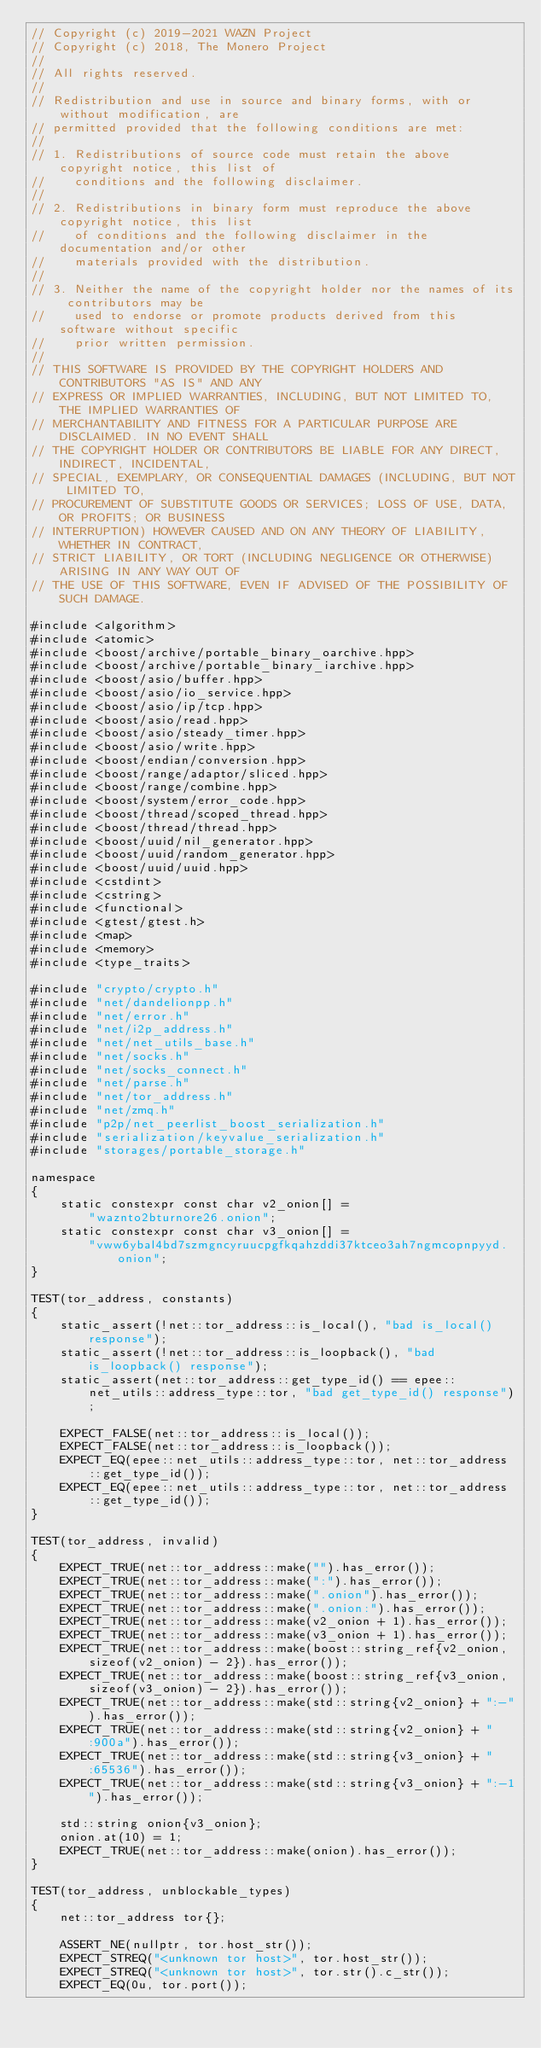<code> <loc_0><loc_0><loc_500><loc_500><_C++_>// Copyright (c) 2019-2021 WAZN Project
// Copyright (c) 2018, The Monero Project
//
// All rights reserved.
//
// Redistribution and use in source and binary forms, with or without modification, are
// permitted provided that the following conditions are met:
//
// 1. Redistributions of source code must retain the above copyright notice, this list of
//    conditions and the following disclaimer.
//
// 2. Redistributions in binary form must reproduce the above copyright notice, this list
//    of conditions and the following disclaimer in the documentation and/or other
//    materials provided with the distribution.
//
// 3. Neither the name of the copyright holder nor the names of its contributors may be
//    used to endorse or promote products derived from this software without specific
//    prior written permission.
//
// THIS SOFTWARE IS PROVIDED BY THE COPYRIGHT HOLDERS AND CONTRIBUTORS "AS IS" AND ANY
// EXPRESS OR IMPLIED WARRANTIES, INCLUDING, BUT NOT LIMITED TO, THE IMPLIED WARRANTIES OF
// MERCHANTABILITY AND FITNESS FOR A PARTICULAR PURPOSE ARE DISCLAIMED. IN NO EVENT SHALL
// THE COPYRIGHT HOLDER OR CONTRIBUTORS BE LIABLE FOR ANY DIRECT, INDIRECT, INCIDENTAL,
// SPECIAL, EXEMPLARY, OR CONSEQUENTIAL DAMAGES (INCLUDING, BUT NOT LIMITED TO,
// PROCUREMENT OF SUBSTITUTE GOODS OR SERVICES; LOSS OF USE, DATA, OR PROFITS; OR BUSINESS
// INTERRUPTION) HOWEVER CAUSED AND ON ANY THEORY OF LIABILITY, WHETHER IN CONTRACT,
// STRICT LIABILITY, OR TORT (INCLUDING NEGLIGENCE OR OTHERWISE) ARISING IN ANY WAY OUT OF
// THE USE OF THIS SOFTWARE, EVEN IF ADVISED OF THE POSSIBILITY OF SUCH DAMAGE.

#include <algorithm>
#include <atomic>
#include <boost/archive/portable_binary_oarchive.hpp>
#include <boost/archive/portable_binary_iarchive.hpp>
#include <boost/asio/buffer.hpp>
#include <boost/asio/io_service.hpp>
#include <boost/asio/ip/tcp.hpp>
#include <boost/asio/read.hpp>
#include <boost/asio/steady_timer.hpp>
#include <boost/asio/write.hpp>
#include <boost/endian/conversion.hpp>
#include <boost/range/adaptor/sliced.hpp>
#include <boost/range/combine.hpp>
#include <boost/system/error_code.hpp>
#include <boost/thread/scoped_thread.hpp>
#include <boost/thread/thread.hpp>
#include <boost/uuid/nil_generator.hpp>
#include <boost/uuid/random_generator.hpp>
#include <boost/uuid/uuid.hpp>
#include <cstdint>
#include <cstring>
#include <functional>
#include <gtest/gtest.h>
#include <map>
#include <memory>
#include <type_traits>

#include "crypto/crypto.h"
#include "net/dandelionpp.h"
#include "net/error.h"
#include "net/i2p_address.h"
#include "net/net_utils_base.h"
#include "net/socks.h"
#include "net/socks_connect.h"
#include "net/parse.h"
#include "net/tor_address.h"
#include "net/zmq.h"
#include "p2p/net_peerlist_boost_serialization.h"
#include "serialization/keyvalue_serialization.h"
#include "storages/portable_storage.h"

namespace
{
    static constexpr const char v2_onion[] =
        "waznto2bturnore26.onion";
    static constexpr const char v3_onion[] =
        "vww6ybal4bd7szmgncyruucpgfkqahzddi37ktceo3ah7ngmcopnpyyd.onion";
}

TEST(tor_address, constants)
{
    static_assert(!net::tor_address::is_local(), "bad is_local() response");
    static_assert(!net::tor_address::is_loopback(), "bad is_loopback() response");
    static_assert(net::tor_address::get_type_id() == epee::net_utils::address_type::tor, "bad get_type_id() response");

    EXPECT_FALSE(net::tor_address::is_local());
    EXPECT_FALSE(net::tor_address::is_loopback());
    EXPECT_EQ(epee::net_utils::address_type::tor, net::tor_address::get_type_id());
    EXPECT_EQ(epee::net_utils::address_type::tor, net::tor_address::get_type_id());
}

TEST(tor_address, invalid)
{
    EXPECT_TRUE(net::tor_address::make("").has_error());
    EXPECT_TRUE(net::tor_address::make(":").has_error());
    EXPECT_TRUE(net::tor_address::make(".onion").has_error());
    EXPECT_TRUE(net::tor_address::make(".onion:").has_error());
    EXPECT_TRUE(net::tor_address::make(v2_onion + 1).has_error());
    EXPECT_TRUE(net::tor_address::make(v3_onion + 1).has_error());
    EXPECT_TRUE(net::tor_address::make(boost::string_ref{v2_onion, sizeof(v2_onion) - 2}).has_error());
    EXPECT_TRUE(net::tor_address::make(boost::string_ref{v3_onion, sizeof(v3_onion) - 2}).has_error());
    EXPECT_TRUE(net::tor_address::make(std::string{v2_onion} + ":-").has_error());
    EXPECT_TRUE(net::tor_address::make(std::string{v2_onion} + ":900a").has_error());
    EXPECT_TRUE(net::tor_address::make(std::string{v3_onion} + ":65536").has_error());
    EXPECT_TRUE(net::tor_address::make(std::string{v3_onion} + ":-1").has_error());

    std::string onion{v3_onion};
    onion.at(10) = 1;
    EXPECT_TRUE(net::tor_address::make(onion).has_error());
}

TEST(tor_address, unblockable_types)
{
    net::tor_address tor{};

    ASSERT_NE(nullptr, tor.host_str());
    EXPECT_STREQ("<unknown tor host>", tor.host_str());
    EXPECT_STREQ("<unknown tor host>", tor.str().c_str());
    EXPECT_EQ(0u, tor.port());</code> 